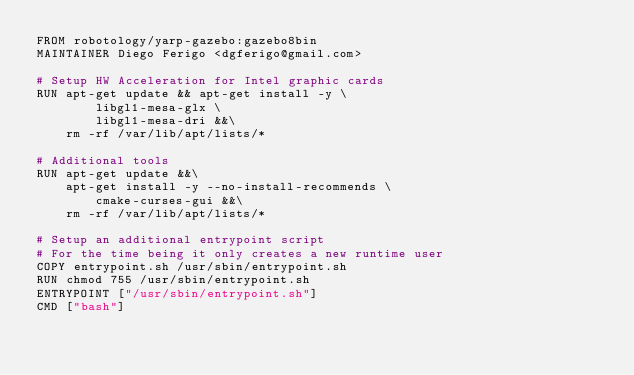<code> <loc_0><loc_0><loc_500><loc_500><_Dockerfile_>FROM robotology/yarp-gazebo:gazebo8bin
MAINTAINER Diego Ferigo <dgferigo@gmail.com>

# Setup HW Acceleration for Intel graphic cards
RUN apt-get update && apt-get install -y \
        libgl1-mesa-glx \
        libgl1-mesa-dri &&\
    rm -rf /var/lib/apt/lists/*

# Additional tools
RUN apt-get update &&\
    apt-get install -y --no-install-recommends \
        cmake-curses-gui &&\
    rm -rf /var/lib/apt/lists/*

# Setup an additional entrypoint script
# For the time being it only creates a new runtime user
COPY entrypoint.sh /usr/sbin/entrypoint.sh
RUN chmod 755 /usr/sbin/entrypoint.sh
ENTRYPOINT ["/usr/sbin/entrypoint.sh"]
CMD ["bash"]
</code> 